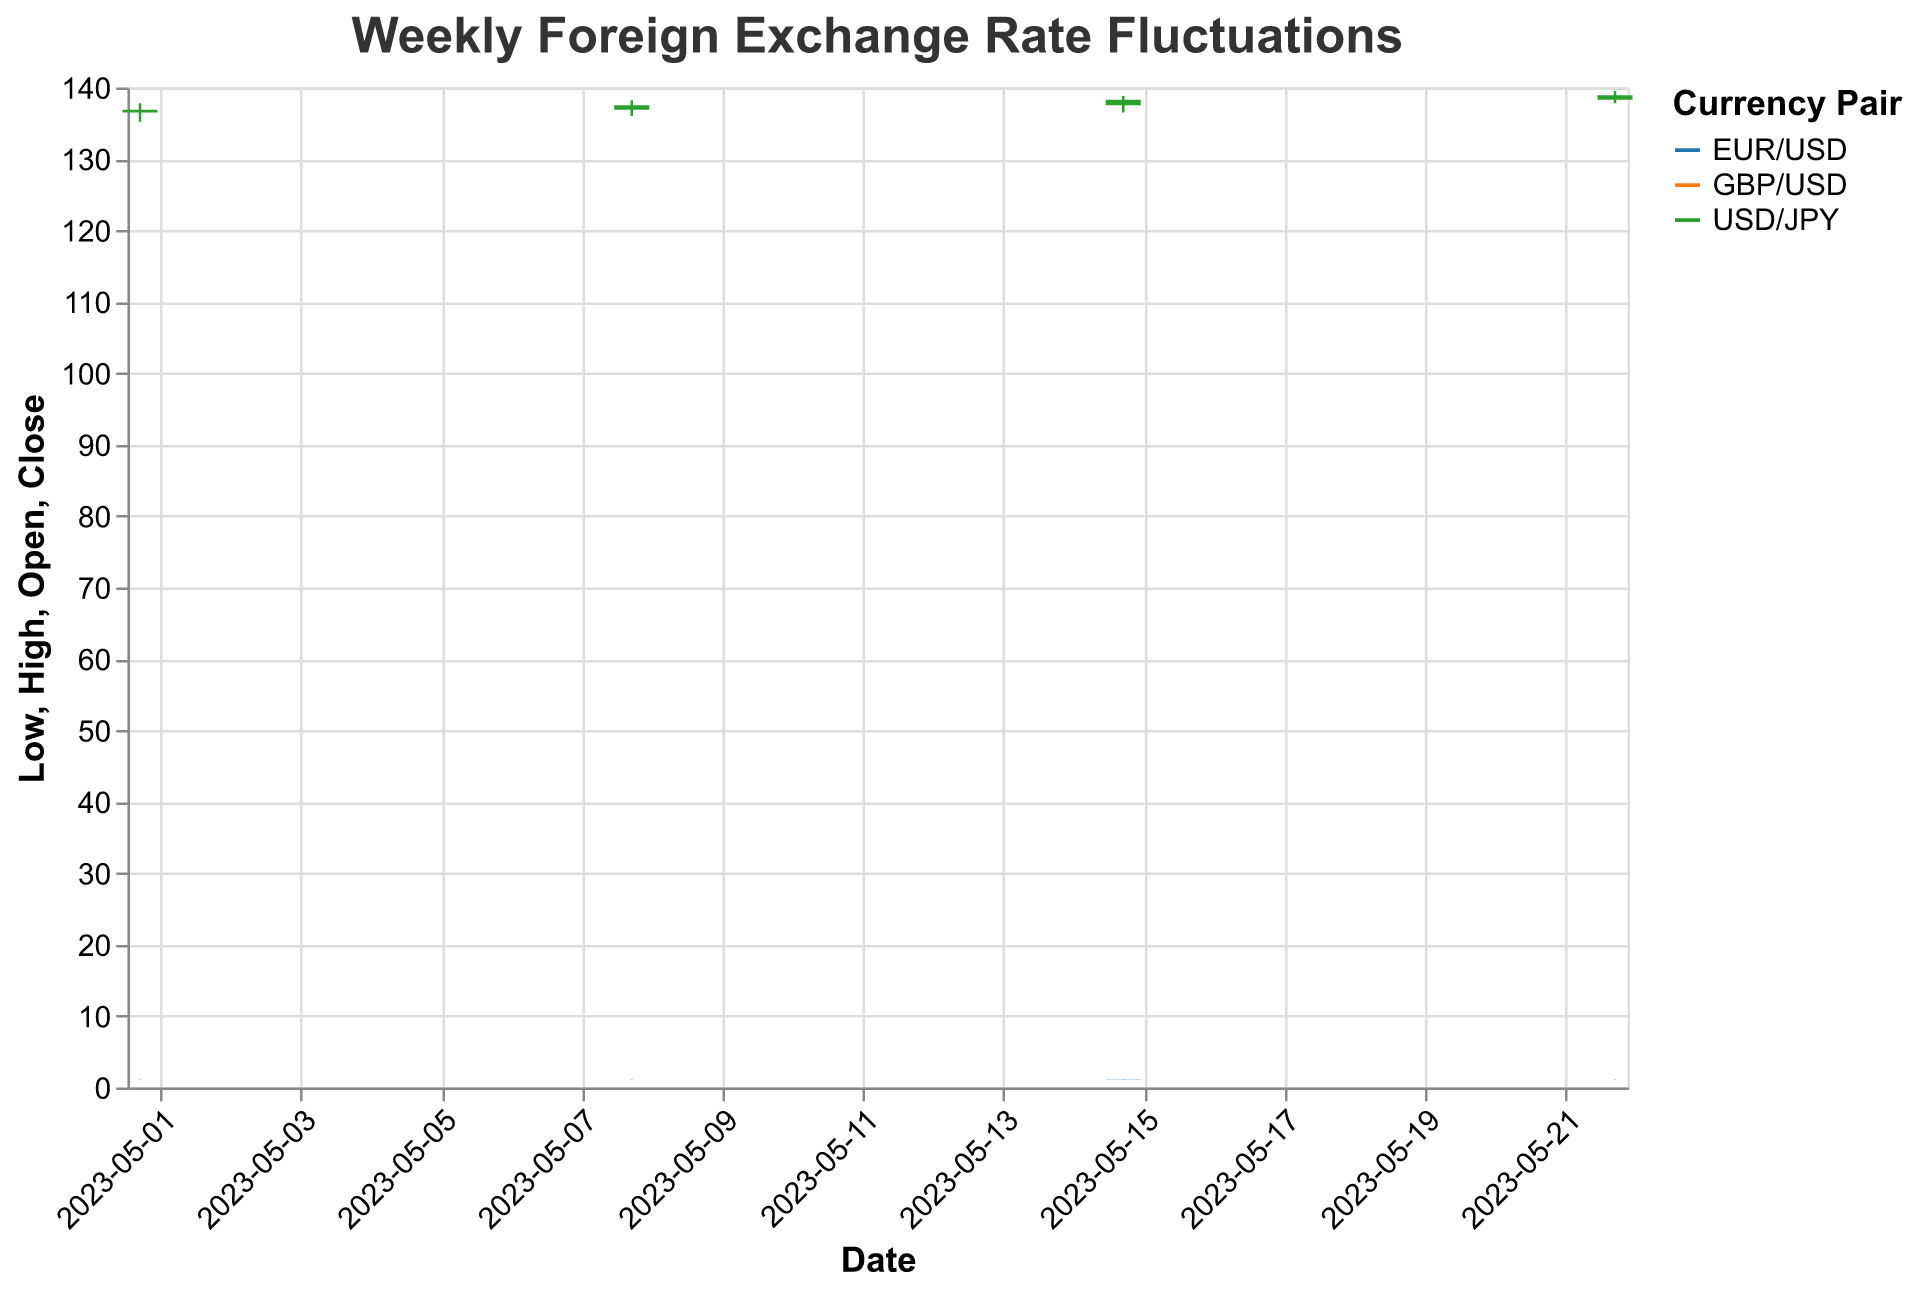What's the title of the chart? The title of the chart is prominently shown at the top, and it reads "Weekly Foreign Exchange Rate Fluctuations".
Answer: Weekly Foreign Exchange Rate Fluctuations Which currency pair has the highest closing value on May 22, 2023? By examining the 'Close' values for May 22, 2023, we see that USD/JPY has the highest closing value at 138.90.
Answer: USD/JPY What was the opening value of EUR/USD on May 1, 2023? From the data, the opening value of EUR/USD on May 1, 2023, is listed as 1.0975.
Answer: 1.0975 Which currency pair experienced the largest weekly range (difference between high and low) on the week starting May 1, 2023? For each currency pair on May 1, 2023, calculate the difference between the high and low values. EUR/USD: 1.1050 - 1.0920 = 0.0130, GBP/USD: 1.2550 - 1.2400 = 0.0150, USD/JPY: 137.80 - 135.20 = 2.60. The largest range is for USD/JPY at 2.60.
Answer: USD/JPY Between EUR/USD and GBP/USD, which had a higher closing value on May 15, 2023? Compare the closing values for EUR/USD and GBP/USD on May 15, 2023. EUR/USD closed at 1.1080 and GBP/USD closed at 1.2620. GBP/USD has a higher closing value.
Answer: GBP/USD Did the EUR/USD close higher than its opening value during the week of May 1, 2023? Check the open and close values for EUR/USD on May 1, 2023. The open value was 1.0975, and the close value was 1.1020. The close value is higher.
Answer: Yes What is the average closing value of USD/JPY over the four weeks of data provided? To find the average closing value, add the close values for USD/JPY and divide by 4. The closing values are 136.90, 137.50, 138.30, and 138.90. Sum these to get 551.60, then divide by 4, resulting in 137.9.
Answer: 137.9 Compare the volatility (range between high and low within a week) of GBP/USD on May 15, 2023, and EUR/USD on May 22, 2023. Which is greater? GBP/USD on May 15, 2023: 1.2650 - 1.2500 = 0.0150. EUR/USD on May 22, 2023: 1.1150 - 1.1000 = 0.0150. Both have the same range.
Answer: They are equal In which week did the USD/JPY show the highest closing value? By checking the closing values of USD/JPY across all listed dates, the highest closing value is on May 22, 2023, at 138.90.
Answer: May 22, 2023 Which currency pair had the most significant upward movement from opening to closing between the weeks listed? For each currency pair, calculate the difference between the opening and closing values each week and find the maximum positive change. After computation, EUR/USD's largest move is 0.0090 on May 15, GBP/USD's largest move is 0.0110 on May 22, and USD/JPY's largest move is 1.80 on May 22. USD/JPY has the most significant upward movement.
Answer: USD/JPY 